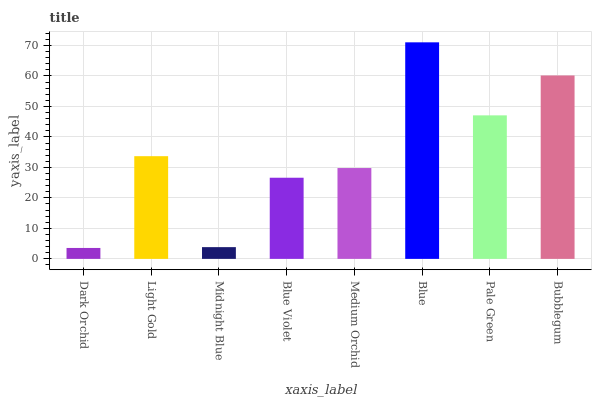Is Dark Orchid the minimum?
Answer yes or no. Yes. Is Blue the maximum?
Answer yes or no. Yes. Is Light Gold the minimum?
Answer yes or no. No. Is Light Gold the maximum?
Answer yes or no. No. Is Light Gold greater than Dark Orchid?
Answer yes or no. Yes. Is Dark Orchid less than Light Gold?
Answer yes or no. Yes. Is Dark Orchid greater than Light Gold?
Answer yes or no. No. Is Light Gold less than Dark Orchid?
Answer yes or no. No. Is Light Gold the high median?
Answer yes or no. Yes. Is Medium Orchid the low median?
Answer yes or no. Yes. Is Bubblegum the high median?
Answer yes or no. No. Is Dark Orchid the low median?
Answer yes or no. No. 